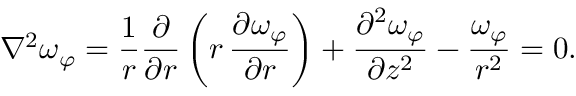Convert formula to latex. <formula><loc_0><loc_0><loc_500><loc_500>\nabla ^ { 2 } \omega _ { \varphi } = { \frac { 1 } { r } } { \frac { \partial } { \partial r } } \left ( r \, { \frac { \partial \omega _ { \varphi } } { \partial r } } \right ) + { \frac { \partial ^ { 2 } \omega _ { \varphi } } { \partial z ^ { 2 } } } - { \frac { \omega _ { \varphi } } { r ^ { 2 } } } = 0 .</formula> 